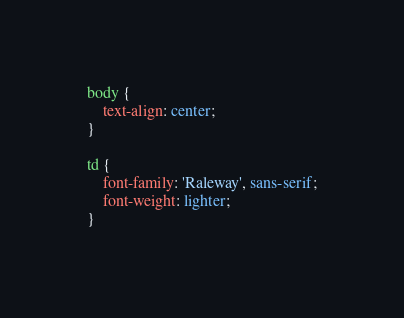<code> <loc_0><loc_0><loc_500><loc_500><_CSS_>body {
    text-align: center;
}

td {
    font-family: 'Raleway', sans-serif;
    font-weight: lighter;
}</code> 